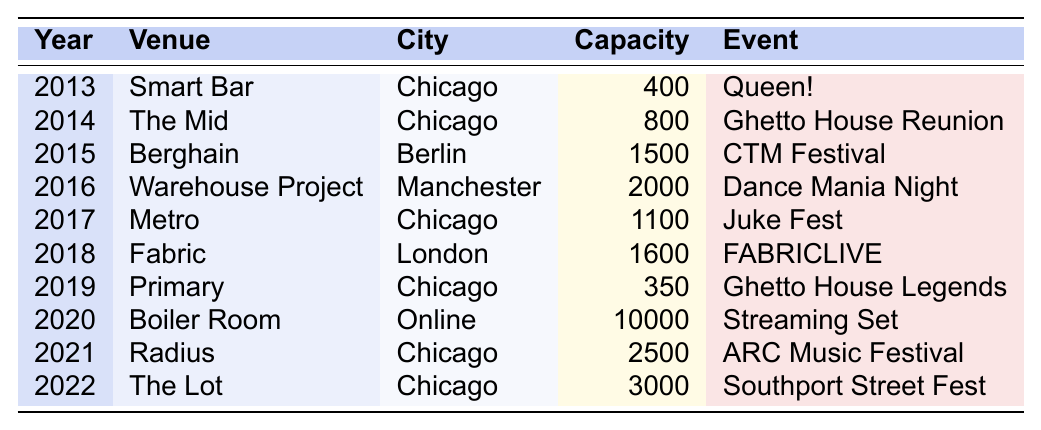What venue had the highest capacity on DJ Deeon's tour? The highest capacity venue listed in the table is Boiler Room with a capacity of 10,000.
Answer: 10,000 In which year did DJ Deeon perform the most events in Chicago? DJ Deeon performed in Chicago in the years 2013 (1 event), 2014 (1 event), 2017 (1 event), 2019 (1 event), 2021 (1 event), and 2022 (1 event). The years 2017, 2021, and 2022 each have the most events (1 event each) but not more than those.
Answer: 1 event Which event took place in 2017? The event that took place in 2017 is "Juke Fest" at the Metro in Chicago.
Answer: Juke Fest How many events did DJ Deeon perform in venues with a capacity of 1500 or more? The events with a capacity of 1500 or more are CTM Festival (1500), Dance Mania Night (2000), ARC Music Festival (2500), and Southport Street Fest (3000). That counts to 4 events.
Answer: 4 events Was DJ Deeon active in performing events online? Yes, DJ Deeon performed an online event called "Streaming Set" in 2020.
Answer: Yes What was the average venue capacity for DJ Deeon's performances in Chicago? The capacities for the Chicago venues are 400, 800, 1100, 350, 2500, and 3000. Summing those gives 400 + 800 + 1100 + 350 + 2500 + 3000 = 8150. Dividing by the number of events (6) gives an average of 8150/6 = 1358.33.
Answer: 1358.33 Which city hosted the most events by DJ Deeon? Chicago hosted 6 events (in 2013, 2014, 2017, 2019, 2021, and 2022), while Berlin, Manchester, and London hosted 1 event each, and online hosted 1 as well.
Answer: Chicago What event took place at the venue with the second largest capacity? The second largest capacity event is "ARC Music Festival" at Radius in Chicago with a capacity of 2500.
Answer: ARC Music Festival How many more people could attend the largest capacity venue compared to the smallest in the table? The largest capacity venue is Boiler Room (10,000) and the smallest capacity venue is Primary (350). The difference is 10,000 - 350 = 9650.
Answer: 9650 Which event was held in London? The event held in London was "FABRICLIVE" at Fabric in 2018.
Answer: FABRICLIVE In what year did DJ Deeon first perform at The Mid? DJ Deeon had his first performance at The Mid in 2014.
Answer: 2014 